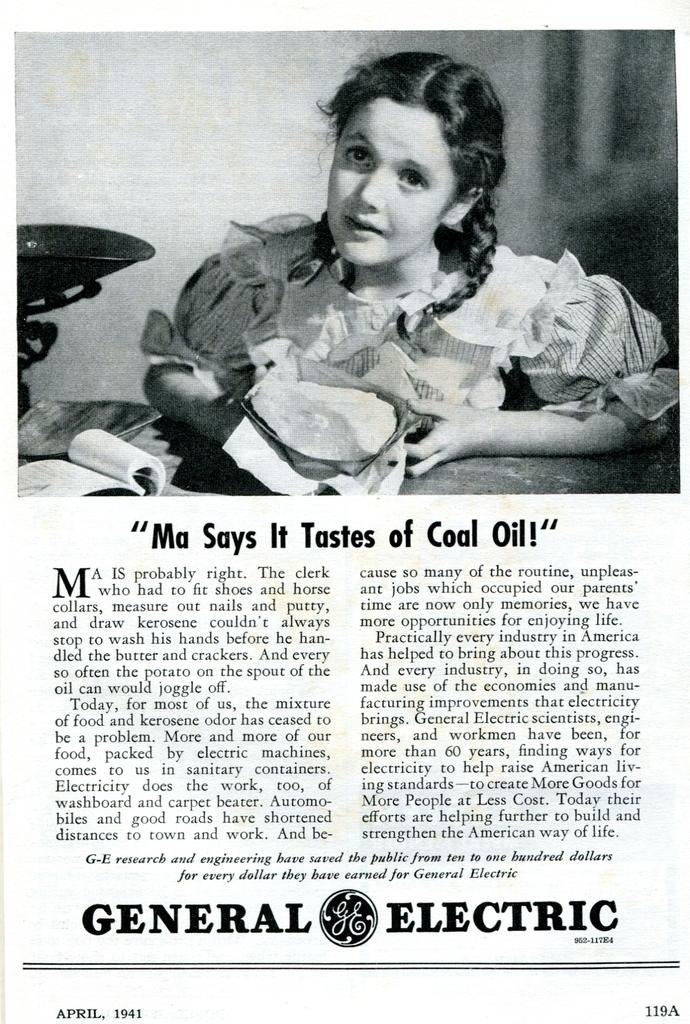Who is the main subject in the picture? There is a girl in the picture. Where is the girl located in relation to the table? The girl is sitting near a table. What items can be seen on the table? There is a book and tissue paper on the table. What is the content of the bottom of the image? The bottom of the image contains a page with an English passage. What type of quilt is being used to cover the girl in the image? There is no quilt present in the image; the girl is not covered by any fabric. 